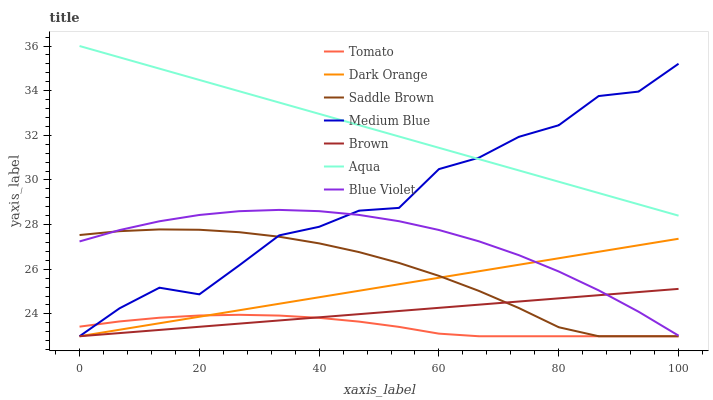Does Tomato have the minimum area under the curve?
Answer yes or no. Yes. Does Aqua have the maximum area under the curve?
Answer yes or no. Yes. Does Dark Orange have the minimum area under the curve?
Answer yes or no. No. Does Dark Orange have the maximum area under the curve?
Answer yes or no. No. Is Dark Orange the smoothest?
Answer yes or no. Yes. Is Medium Blue the roughest?
Answer yes or no. Yes. Is Brown the smoothest?
Answer yes or no. No. Is Brown the roughest?
Answer yes or no. No. Does Tomato have the lowest value?
Answer yes or no. Yes. Does Aqua have the lowest value?
Answer yes or no. No. Does Aqua have the highest value?
Answer yes or no. Yes. Does Dark Orange have the highest value?
Answer yes or no. No. Is Tomato less than Aqua?
Answer yes or no. Yes. Is Aqua greater than Tomato?
Answer yes or no. Yes. Does Tomato intersect Dark Orange?
Answer yes or no. Yes. Is Tomato less than Dark Orange?
Answer yes or no. No. Is Tomato greater than Dark Orange?
Answer yes or no. No. Does Tomato intersect Aqua?
Answer yes or no. No. 